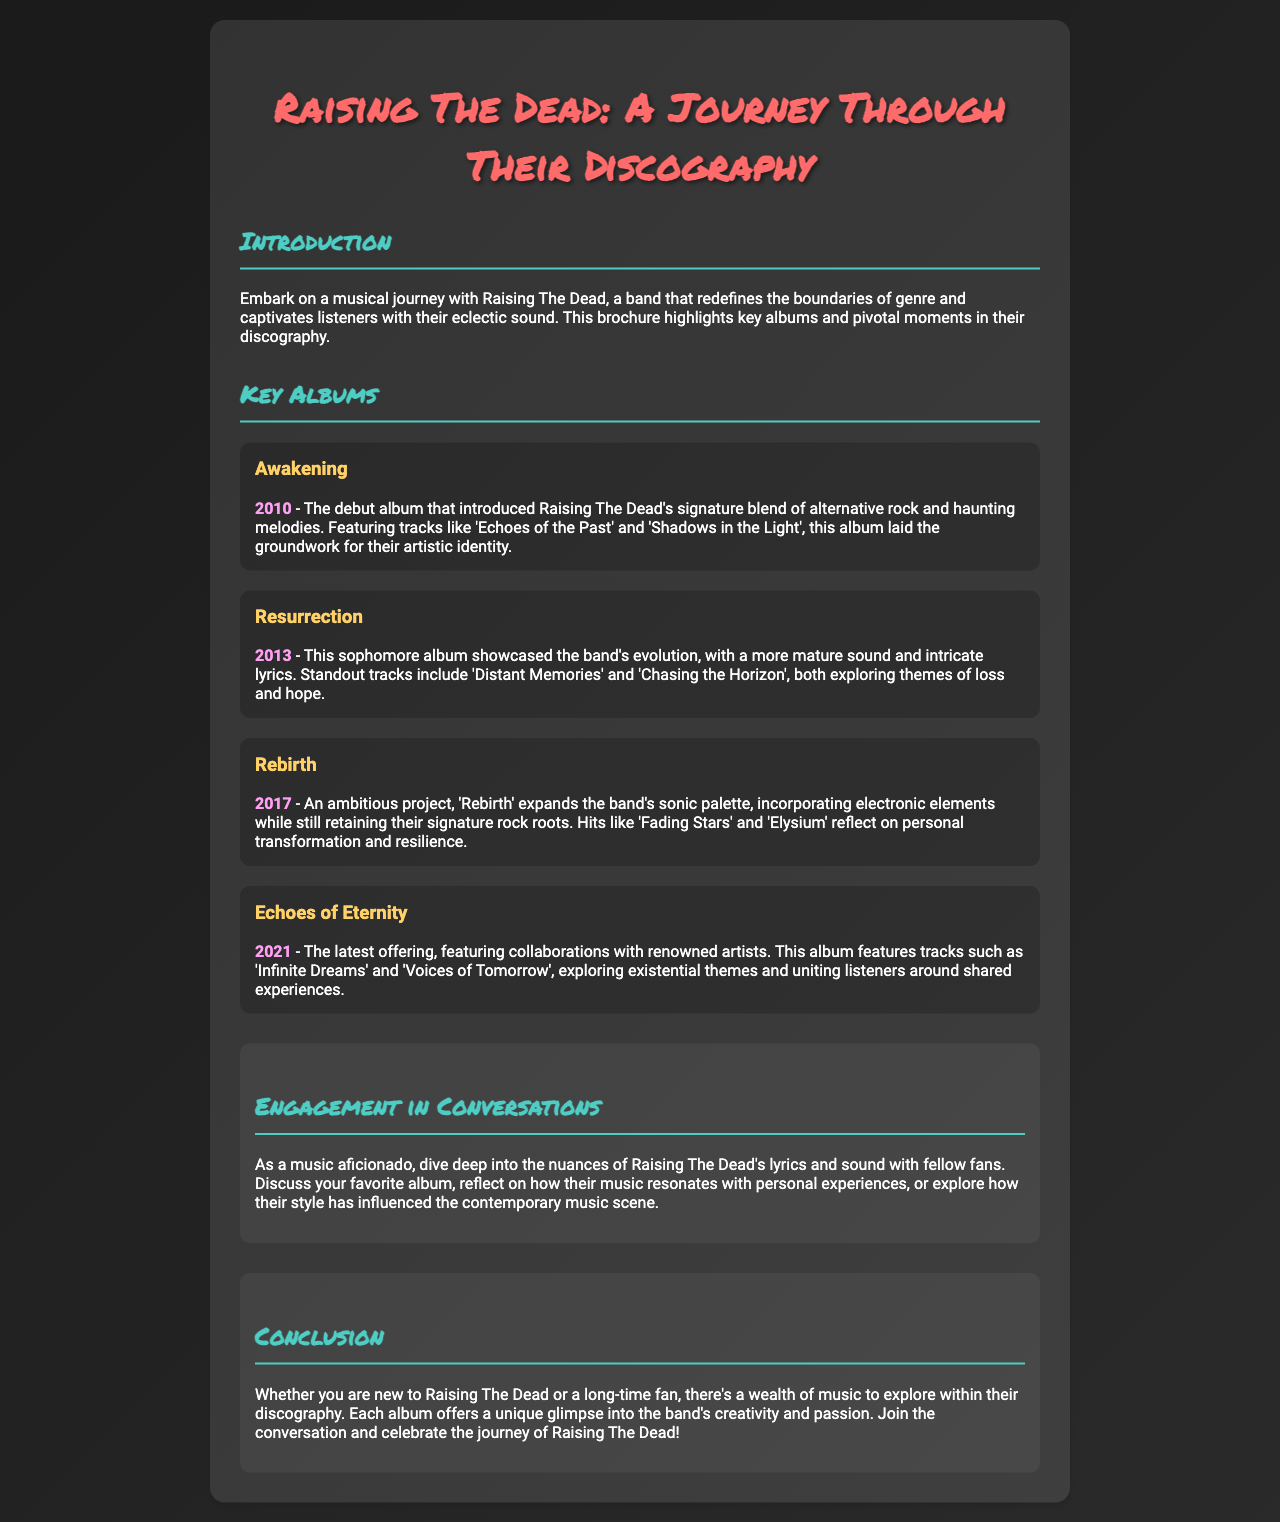What is the title of the brochure? The title is the main heading of the document, highlighting the subject matter.
Answer: Raising The Dead: A Journey Through Their Discography What year was the album "Resurrection" released? The year of release is mentioned in parentheses after the album title.
Answer: 2013 Which album features the song "Fading Stars"? The song is listed with its corresponding album, providing a direct connection.
Answer: Rebirth What genre does Raising The Dead's music mainly represent? The introduction describes the band's style and sound qualities.
Answer: Alternative rock What thematic elements do "Distant Memories" and "Chasing the Horizon" explore? The themes are stated in relation to the band's evolution in their sophomore album.
Answer: Loss and hope How many key albums are highlighted in the brochure? This number can be derived from the section listing key albums.
Answer: Four Which album includes collaborations with renowned artists? This information specifies a feature of the latest album discussed in the document.
Answer: Echoes of Eternity What is the focus of the engagement section? The engagement section prompts specific actions or discussions for readers.
Answer: Conversations about lyrics and sound What color is used for the album titles? The specific color used for album titles is mentioned in the visual styling of the document.
Answer: Yellow 